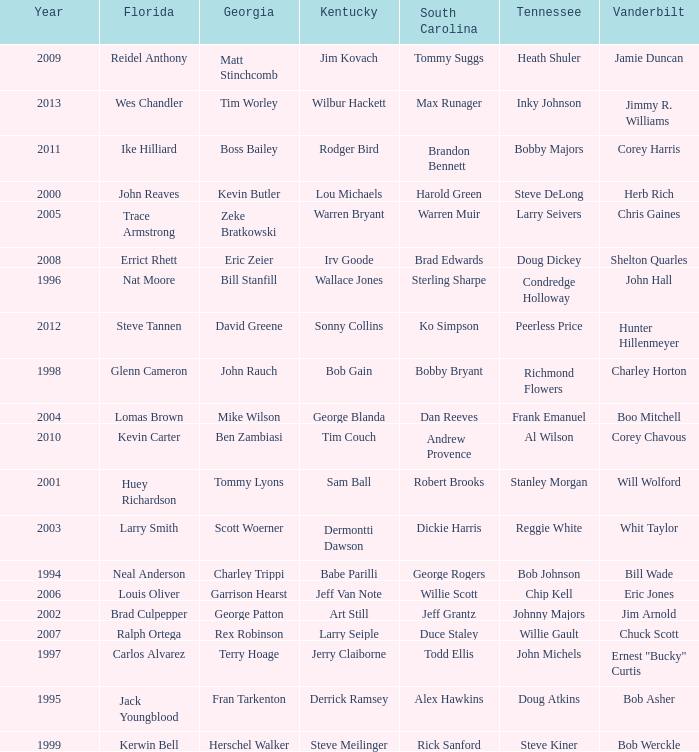What is the Tennessee that Georgia of kevin butler is in? Steve DeLong. 